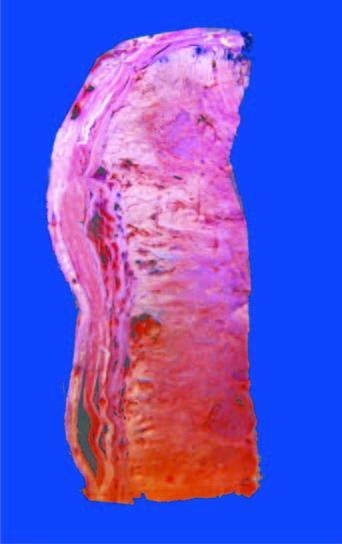what is grey-white, cystic, soft and friable?
Answer the question using a single word or phrase. Cut surface of the tumour 